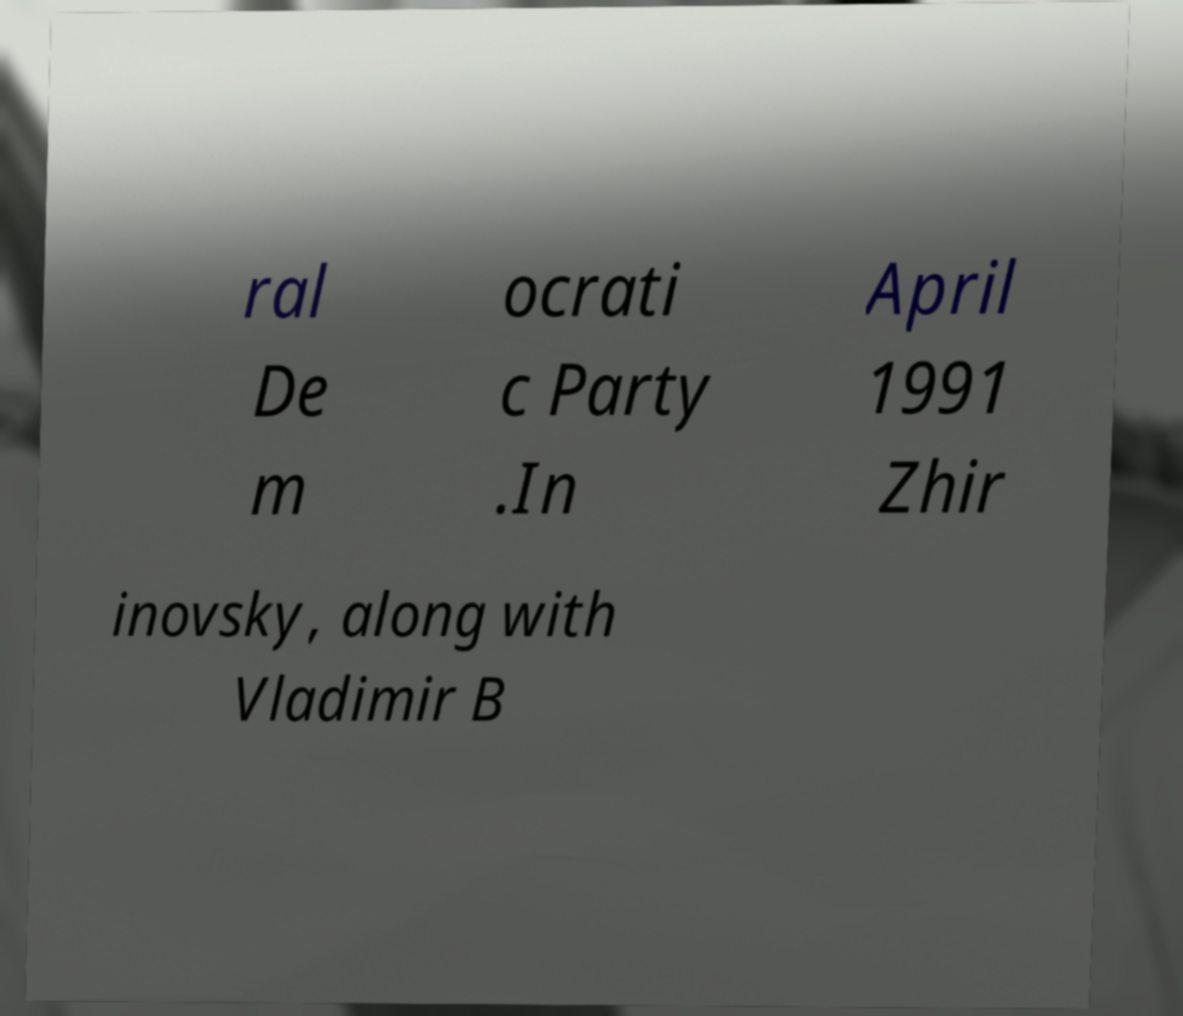What messages or text are displayed in this image? I need them in a readable, typed format. ral De m ocrati c Party .In April 1991 Zhir inovsky, along with Vladimir B 